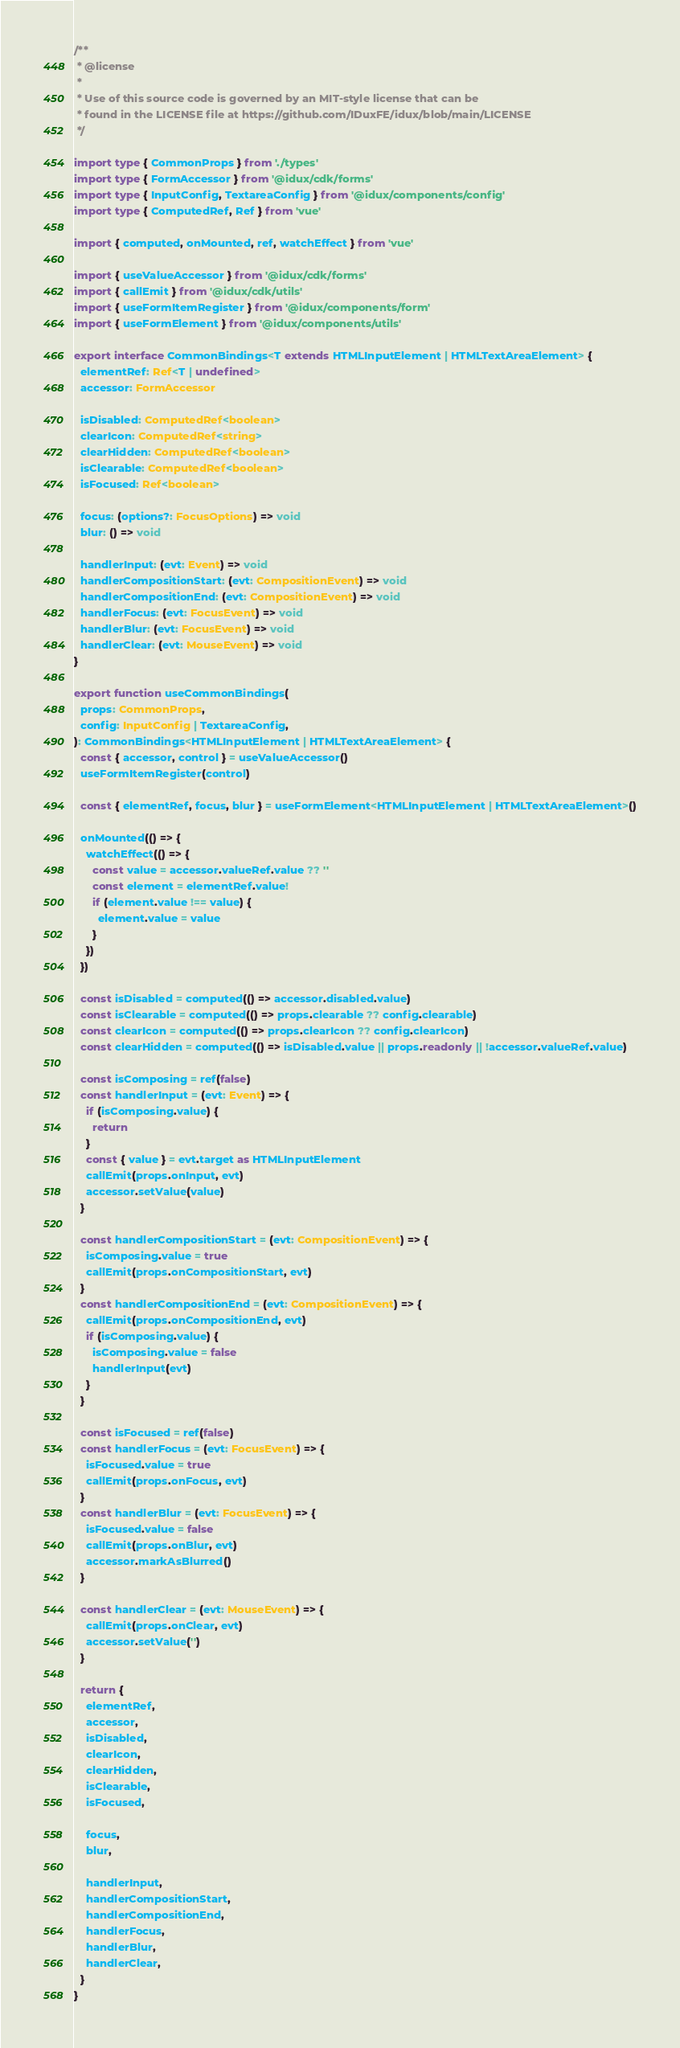Convert code to text. <code><loc_0><loc_0><loc_500><loc_500><_TypeScript_>/**
 * @license
 *
 * Use of this source code is governed by an MIT-style license that can be
 * found in the LICENSE file at https://github.com/IDuxFE/idux/blob/main/LICENSE
 */

import type { CommonProps } from './types'
import type { FormAccessor } from '@idux/cdk/forms'
import type { InputConfig, TextareaConfig } from '@idux/components/config'
import type { ComputedRef, Ref } from 'vue'

import { computed, onMounted, ref, watchEffect } from 'vue'

import { useValueAccessor } from '@idux/cdk/forms'
import { callEmit } from '@idux/cdk/utils'
import { useFormItemRegister } from '@idux/components/form'
import { useFormElement } from '@idux/components/utils'

export interface CommonBindings<T extends HTMLInputElement | HTMLTextAreaElement> {
  elementRef: Ref<T | undefined>
  accessor: FormAccessor

  isDisabled: ComputedRef<boolean>
  clearIcon: ComputedRef<string>
  clearHidden: ComputedRef<boolean>
  isClearable: ComputedRef<boolean>
  isFocused: Ref<boolean>

  focus: (options?: FocusOptions) => void
  blur: () => void

  handlerInput: (evt: Event) => void
  handlerCompositionStart: (evt: CompositionEvent) => void
  handlerCompositionEnd: (evt: CompositionEvent) => void
  handlerFocus: (evt: FocusEvent) => void
  handlerBlur: (evt: FocusEvent) => void
  handlerClear: (evt: MouseEvent) => void
}

export function useCommonBindings(
  props: CommonProps,
  config: InputConfig | TextareaConfig,
): CommonBindings<HTMLInputElement | HTMLTextAreaElement> {
  const { accessor, control } = useValueAccessor()
  useFormItemRegister(control)

  const { elementRef, focus, blur } = useFormElement<HTMLInputElement | HTMLTextAreaElement>()

  onMounted(() => {
    watchEffect(() => {
      const value = accessor.valueRef.value ?? ''
      const element = elementRef.value!
      if (element.value !== value) {
        element.value = value
      }
    })
  })

  const isDisabled = computed(() => accessor.disabled.value)
  const isClearable = computed(() => props.clearable ?? config.clearable)
  const clearIcon = computed(() => props.clearIcon ?? config.clearIcon)
  const clearHidden = computed(() => isDisabled.value || props.readonly || !accessor.valueRef.value)

  const isComposing = ref(false)
  const handlerInput = (evt: Event) => {
    if (isComposing.value) {
      return
    }
    const { value } = evt.target as HTMLInputElement
    callEmit(props.onInput, evt)
    accessor.setValue(value)
  }

  const handlerCompositionStart = (evt: CompositionEvent) => {
    isComposing.value = true
    callEmit(props.onCompositionStart, evt)
  }
  const handlerCompositionEnd = (evt: CompositionEvent) => {
    callEmit(props.onCompositionEnd, evt)
    if (isComposing.value) {
      isComposing.value = false
      handlerInput(evt)
    }
  }

  const isFocused = ref(false)
  const handlerFocus = (evt: FocusEvent) => {
    isFocused.value = true
    callEmit(props.onFocus, evt)
  }
  const handlerBlur = (evt: FocusEvent) => {
    isFocused.value = false
    callEmit(props.onBlur, evt)
    accessor.markAsBlurred()
  }

  const handlerClear = (evt: MouseEvent) => {
    callEmit(props.onClear, evt)
    accessor.setValue('')
  }

  return {
    elementRef,
    accessor,
    isDisabled,
    clearIcon,
    clearHidden,
    isClearable,
    isFocused,

    focus,
    blur,

    handlerInput,
    handlerCompositionStart,
    handlerCompositionEnd,
    handlerFocus,
    handlerBlur,
    handlerClear,
  }
}
</code> 